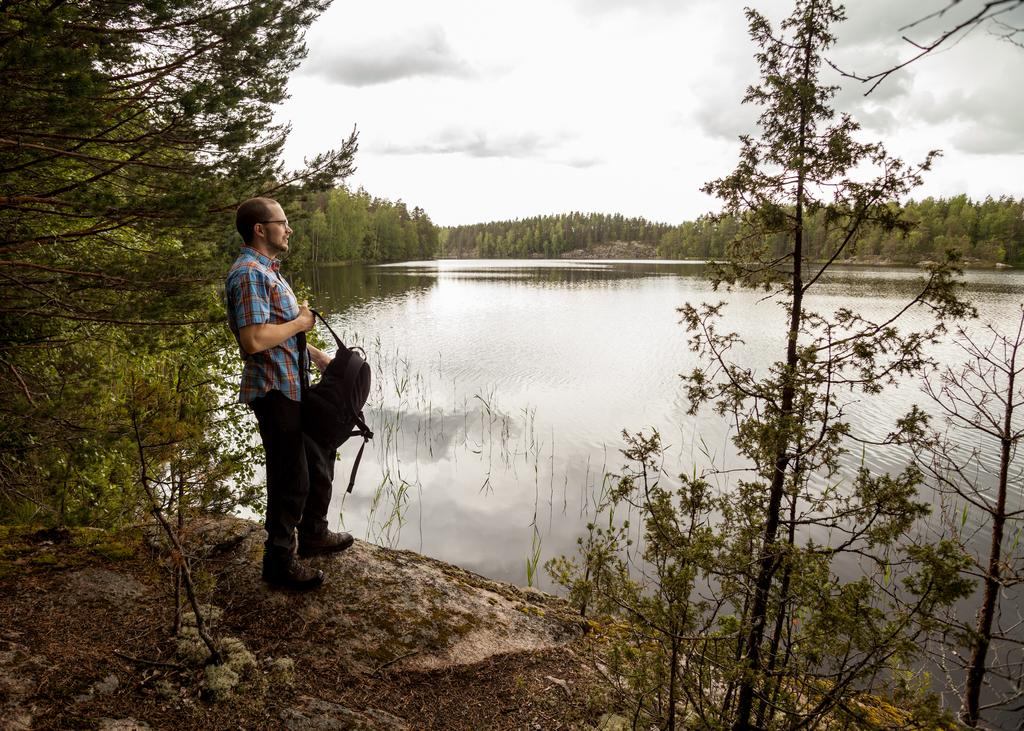Who is present in the image? There is a man in the image. What is the man doing in the image? The man is on the ground. What is the man holding in the image? The man is holding a bag. What can be seen in the background of the image? There is water, trees, and the sky visible in the background of the image. How many cherries are on the ground near the man in the image? There are no cherries present in the image. What type of lizards can be seen crawling on the man in the image? There are no lizards present in the image. 